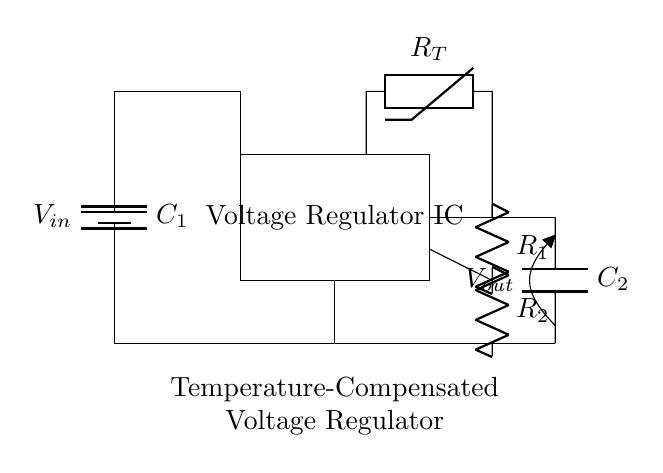What type of component is used for temperature sensing? The circuit includes a thermistor, which is a type of resistor that changes resistance with temperature. This can be identified from the label on the component connected to the temperature sensor section of the diagram.
Answer: thermistor What is the purpose of the capacitors in this circuit? Capacitors C1 and C2 are used to stabilize the voltage. C1 smooths out the input voltage, while C2 stabilizes the output voltage, reducing noise and fluctuations.
Answer: stabilize voltage How many resistors are in the feedback loop? The feedback loop consists of two resistors labeled R1 and R2, which work together to set the output voltage of the voltage regulator by providing feedback to the IC.
Answer: two What happens to the output voltage when the temperature increases? When the temperature increases, the thermistor's resistance decreases, which affects the feedback provided to the voltage regulator IC, potentially resulting in a more stable output voltage. Therefore, the output voltage is compensated for temperature variations.
Answer: stabilizes What type of voltage regulator is represented in the circuit? This is a temperature-compensated voltage regulator, indicated by the specific inclusion of a thermistor for temperature feedback to maintain stable output across varying temperatures.
Answer: temperature-compensated 